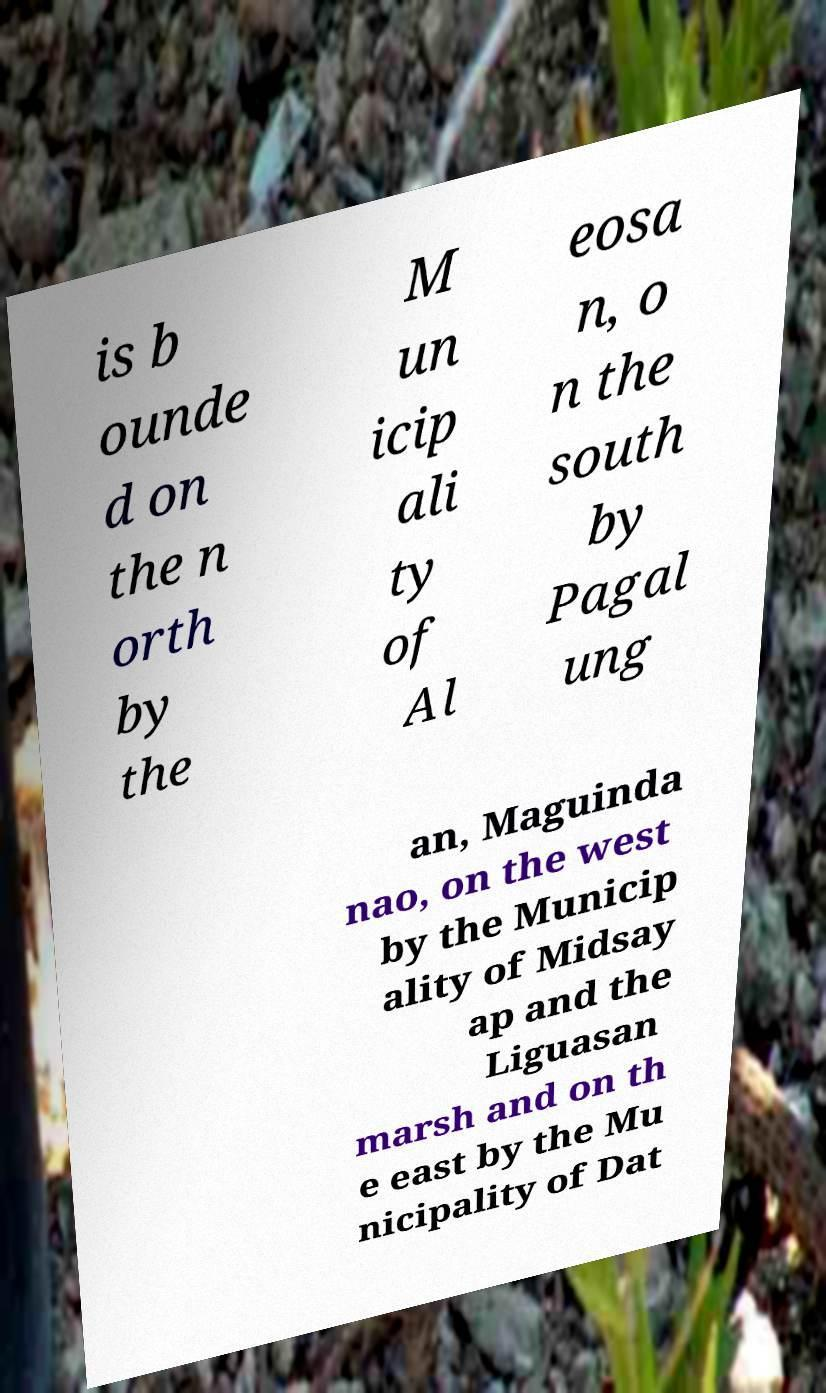Please read and relay the text visible in this image. What does it say? is b ounde d on the n orth by the M un icip ali ty of Al eosa n, o n the south by Pagal ung an, Maguinda nao, on the west by the Municip ality of Midsay ap and the Liguasan marsh and on th e east by the Mu nicipality of Dat 